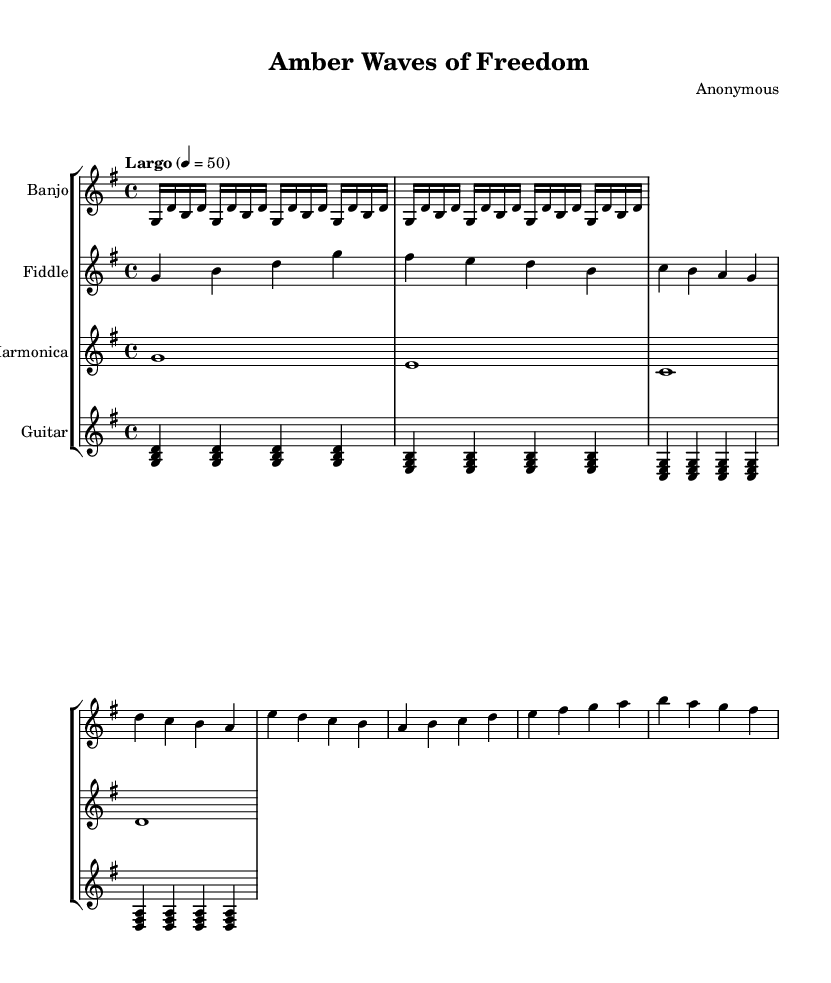What is the key signature of this music? The key signature is G major, which has one sharp (F#). This can be identified by looking at the beginning of the staff, where the sharp is placed.
Answer: G major What is the time signature of this music? The time signature is 4/4, which is indicated at the beginning of the score. This means there are four beats per measure and a quarter note receives one beat.
Answer: 4/4 What is the tempo marking given for the piece? The tempo marking is "Largo," which suggests a slow and broad performance. This is noted above the staff, indicating the overall speed of the piece.
Answer: Largo Which instruments are featured in this arrangement? The instruments featured are Banjo, Fiddle, Harmonica, and Guitar. Each is indicated by a separate staff label at the beginning of the score, showing the instrumentation used.
Answer: Banjo, Fiddle, Harmonica, Guitar How many measures are in the banjo part? The banjo part contains 4 measures, as indicated by the grouping of notes and the layout of the score. Each set of notes separated by vertical lines represents a measure.
Answer: 4 Describe the overall character of the piece based on its instruments and tempo. The piece features American folk instruments which suggest a traditional and nostalgic feel. Coupled with the slow tempo, it likely aims to evoke feelings of tranquility or patriotism, characteristic of ambient soundscapes.
Answer: Nostalgic tranquility What type of harmonic structure is employed in the guitar part? The guitar part employs arpeggiated chords, where notes of a chord are played in succession rather than simultaneously. This is observable through the notation of stacked notes played in sequence.
Answer: Arpeggiated chords 